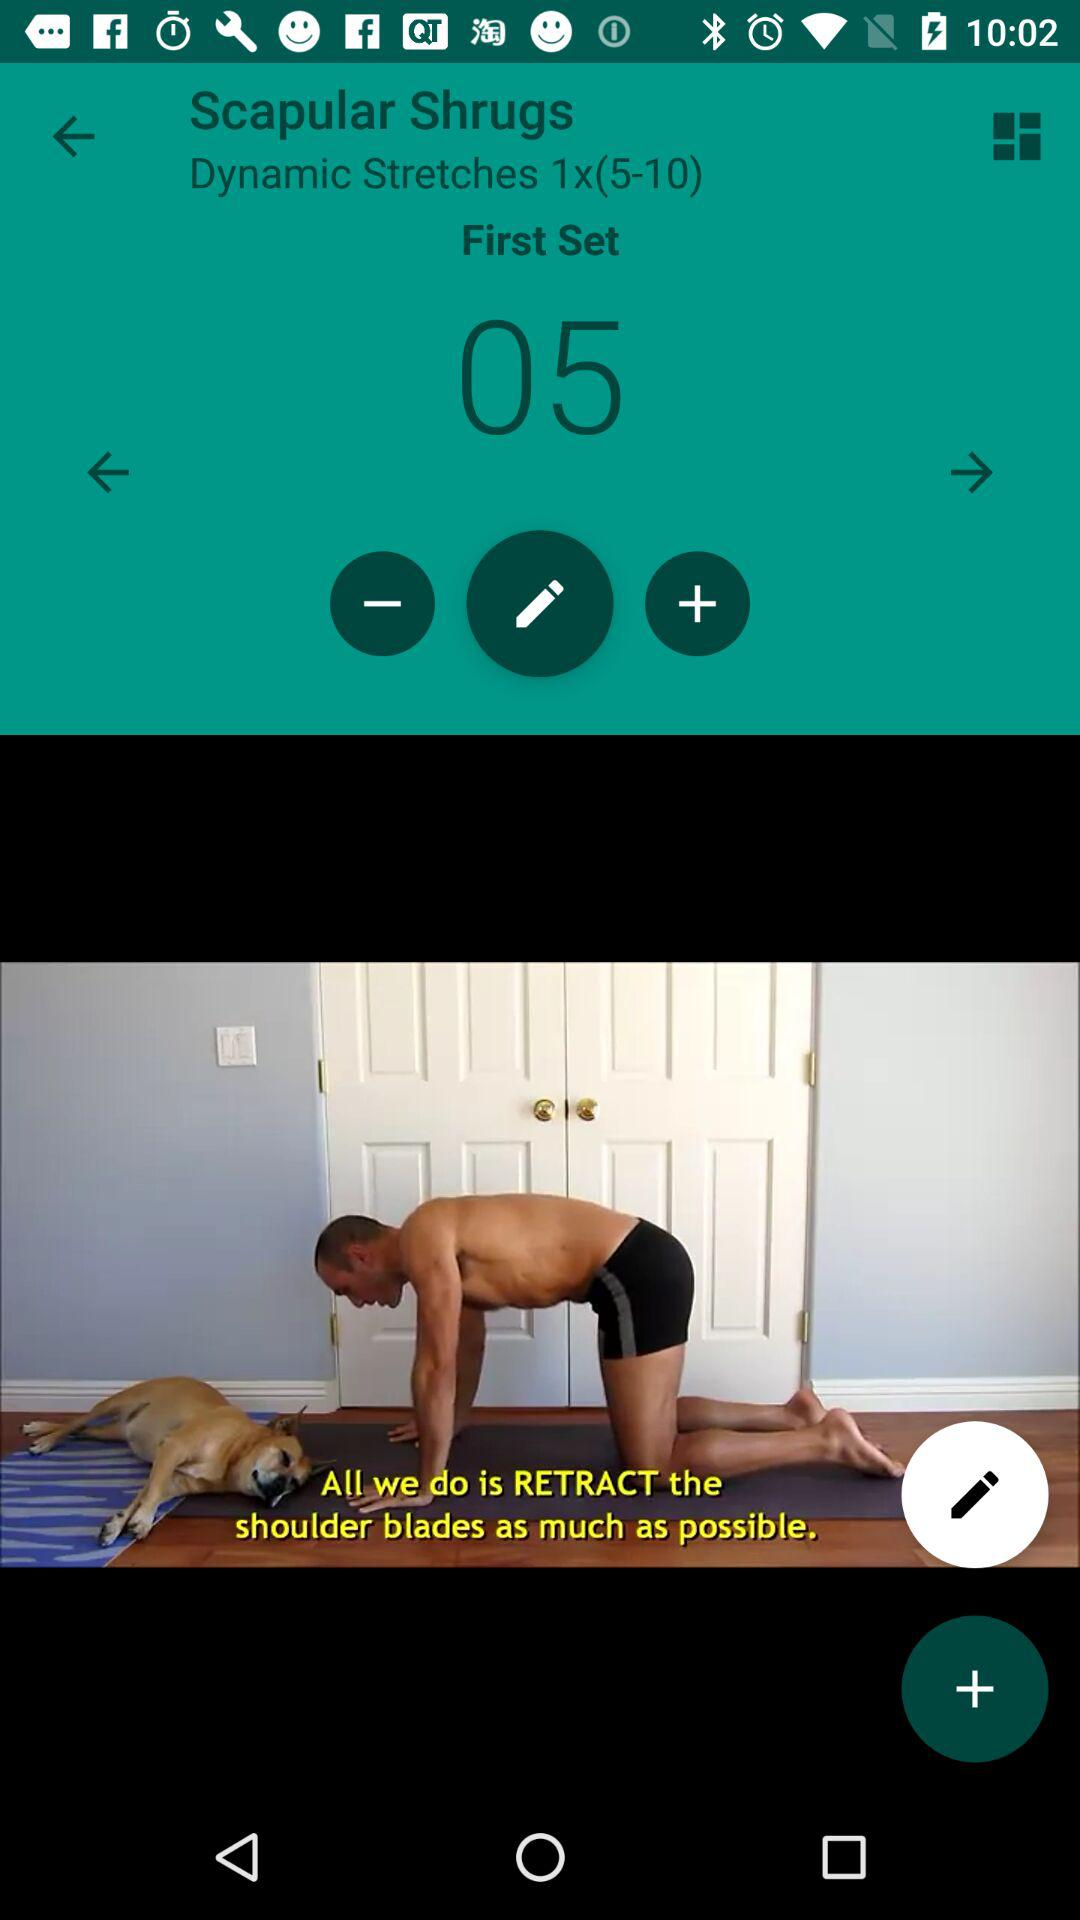How many sets are there in this workout?
Answer the question using a single word or phrase. 1 